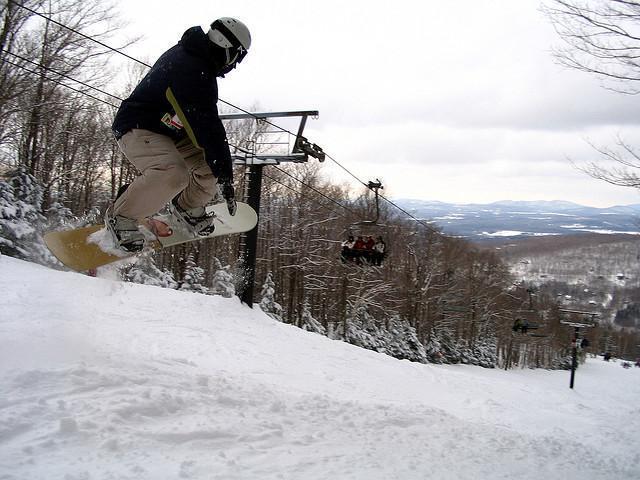How many of the tracks have a train on them?
Give a very brief answer. 0. 